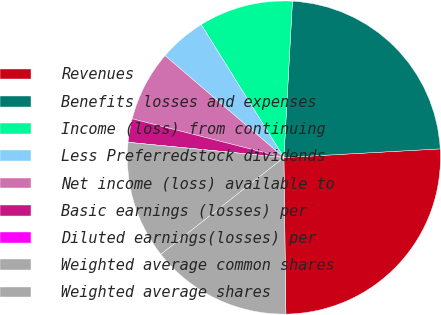Convert chart to OTSL. <chart><loc_0><loc_0><loc_500><loc_500><pie_chart><fcel>Revenues<fcel>Benefits losses and expenses<fcel>Income (loss) from continuing<fcel>Less Preferredstock dividends<fcel>Net income (loss) available to<fcel>Basic earnings (losses) per<fcel>Diluted earnings(losses) per<fcel>Weighted average common shares<fcel>Weighted average shares<nl><fcel>25.68%<fcel>23.25%<fcel>9.73%<fcel>4.86%<fcel>7.3%<fcel>2.43%<fcel>0.0%<fcel>12.16%<fcel>14.59%<nl></chart> 